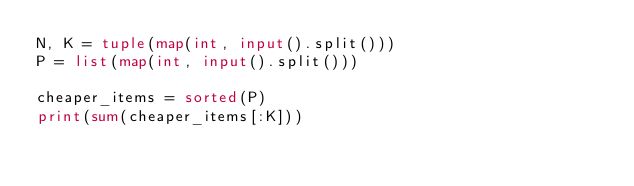Convert code to text. <code><loc_0><loc_0><loc_500><loc_500><_Python_>N, K = tuple(map(int, input().split()))
P = list(map(int, input().split()))

cheaper_items = sorted(P)
print(sum(cheaper_items[:K]))
</code> 